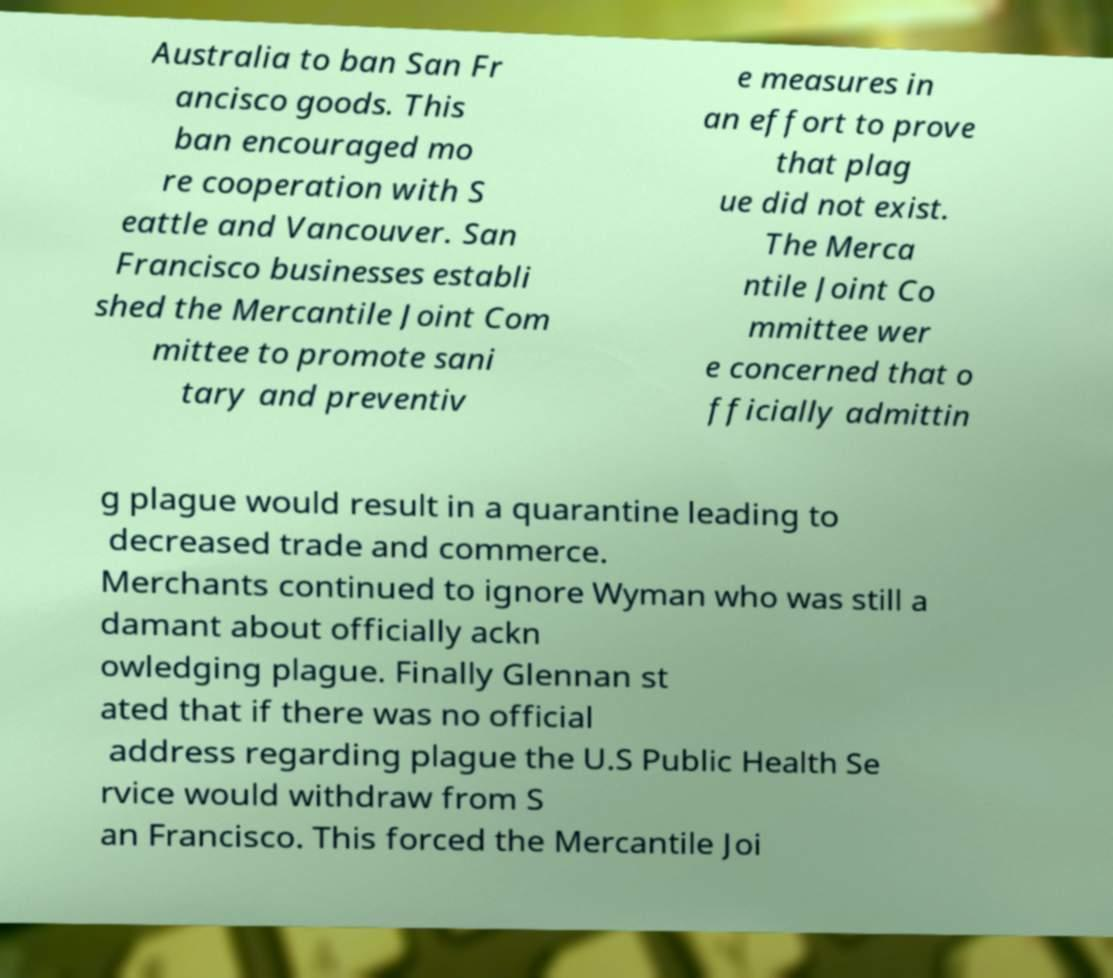Could you assist in decoding the text presented in this image and type it out clearly? Australia to ban San Fr ancisco goods. This ban encouraged mo re cooperation with S eattle and Vancouver. San Francisco businesses establi shed the Mercantile Joint Com mittee to promote sani tary and preventiv e measures in an effort to prove that plag ue did not exist. The Merca ntile Joint Co mmittee wer e concerned that o fficially admittin g plague would result in a quarantine leading to decreased trade and commerce. Merchants continued to ignore Wyman who was still a damant about officially ackn owledging plague. Finally Glennan st ated that if there was no official address regarding plague the U.S Public Health Se rvice would withdraw from S an Francisco. This forced the Mercantile Joi 